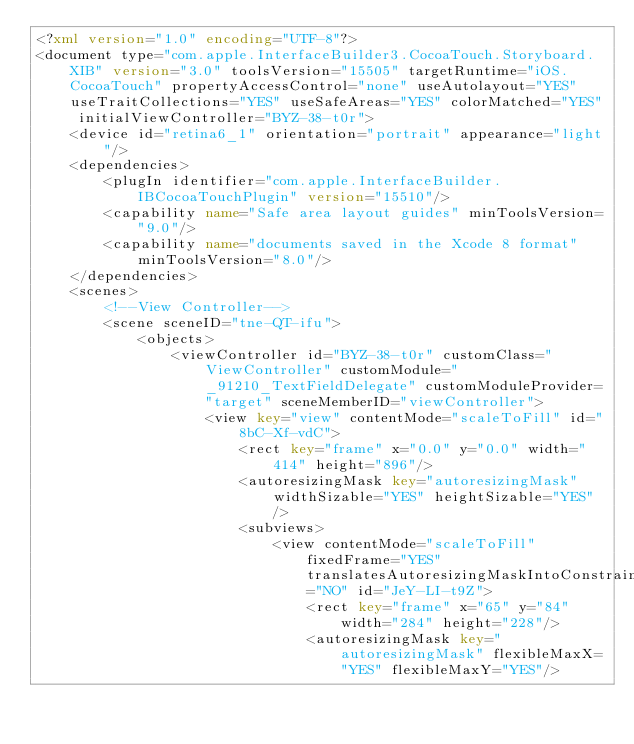Convert code to text. <code><loc_0><loc_0><loc_500><loc_500><_XML_><?xml version="1.0" encoding="UTF-8"?>
<document type="com.apple.InterfaceBuilder3.CocoaTouch.Storyboard.XIB" version="3.0" toolsVersion="15505" targetRuntime="iOS.CocoaTouch" propertyAccessControl="none" useAutolayout="YES" useTraitCollections="YES" useSafeAreas="YES" colorMatched="YES" initialViewController="BYZ-38-t0r">
    <device id="retina6_1" orientation="portrait" appearance="light"/>
    <dependencies>
        <plugIn identifier="com.apple.InterfaceBuilder.IBCocoaTouchPlugin" version="15510"/>
        <capability name="Safe area layout guides" minToolsVersion="9.0"/>
        <capability name="documents saved in the Xcode 8 format" minToolsVersion="8.0"/>
    </dependencies>
    <scenes>
        <!--View Controller-->
        <scene sceneID="tne-QT-ifu">
            <objects>
                <viewController id="BYZ-38-t0r" customClass="ViewController" customModule="_91210_TextFieldDelegate" customModuleProvider="target" sceneMemberID="viewController">
                    <view key="view" contentMode="scaleToFill" id="8bC-Xf-vdC">
                        <rect key="frame" x="0.0" y="0.0" width="414" height="896"/>
                        <autoresizingMask key="autoresizingMask" widthSizable="YES" heightSizable="YES"/>
                        <subviews>
                            <view contentMode="scaleToFill" fixedFrame="YES" translatesAutoresizingMaskIntoConstraints="NO" id="JeY-LI-t9Z">
                                <rect key="frame" x="65" y="84" width="284" height="228"/>
                                <autoresizingMask key="autoresizingMask" flexibleMaxX="YES" flexibleMaxY="YES"/></code> 